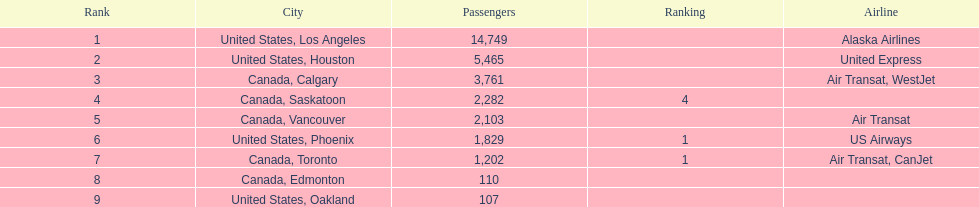What were the complete passenger counts? 14,749, 5,465, 3,761, 2,282, 2,103, 1,829, 1,202, 110, 107. Which of these were heading to los angeles? 14,749. What other destination, when combined with this, comes closest to 19,000? Canada, Calgary. 